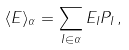Convert formula to latex. <formula><loc_0><loc_0><loc_500><loc_500>\langle E \rangle _ { \alpha } = \sum _ { I \in \alpha } E _ { I } P _ { I } \, ,</formula> 